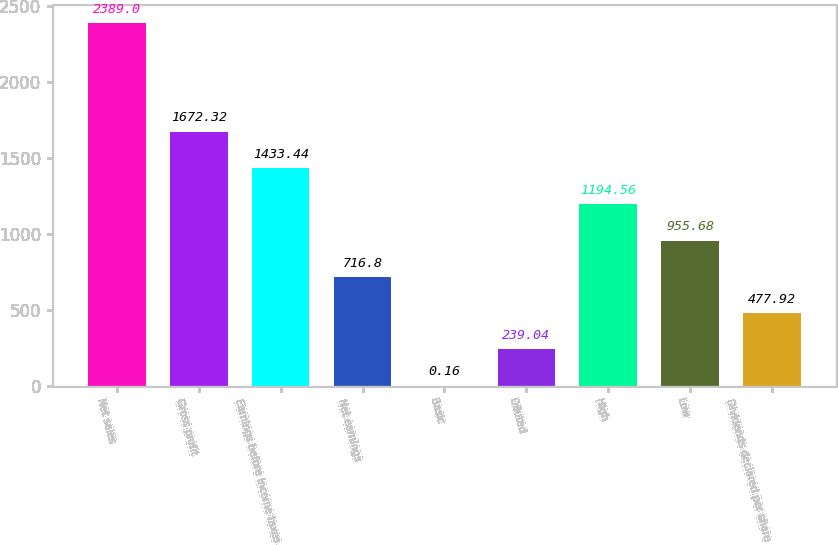Convert chart. <chart><loc_0><loc_0><loc_500><loc_500><bar_chart><fcel>Net sales<fcel>Gross profit<fcel>Earnings before income taxes<fcel>Net earnings<fcel>Basic<fcel>Diluted<fcel>High<fcel>Low<fcel>Dividends declared per share<nl><fcel>2389<fcel>1672.32<fcel>1433.44<fcel>716.8<fcel>0.16<fcel>239.04<fcel>1194.56<fcel>955.68<fcel>477.92<nl></chart> 